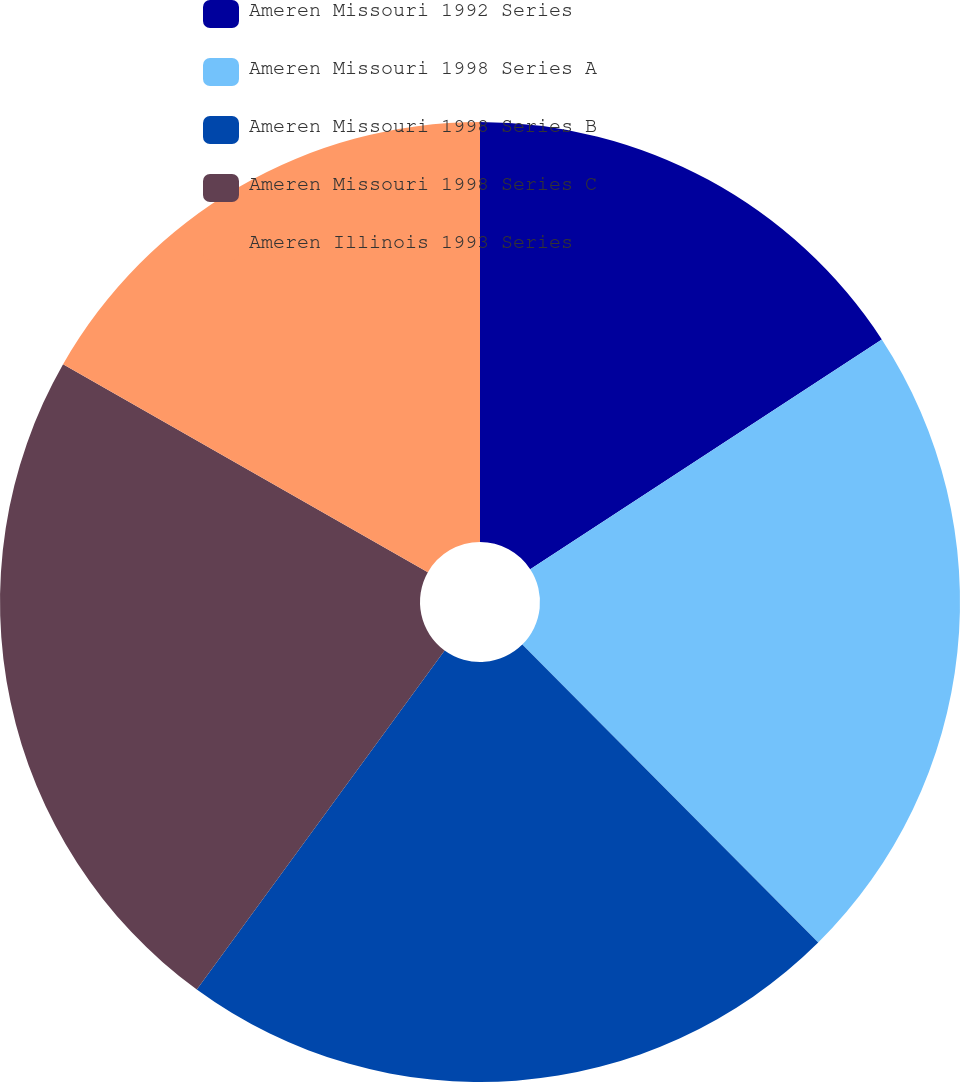<chart> <loc_0><loc_0><loc_500><loc_500><pie_chart><fcel>Ameren Missouri 1992 Series<fcel>Ameren Missouri 1998 Series A<fcel>Ameren Missouri 1998 Series B<fcel>Ameren Missouri 1998 Series C<fcel>Ameren Illinois 1993 Series<nl><fcel>15.79%<fcel>21.77%<fcel>22.49%<fcel>23.21%<fcel>16.75%<nl></chart> 